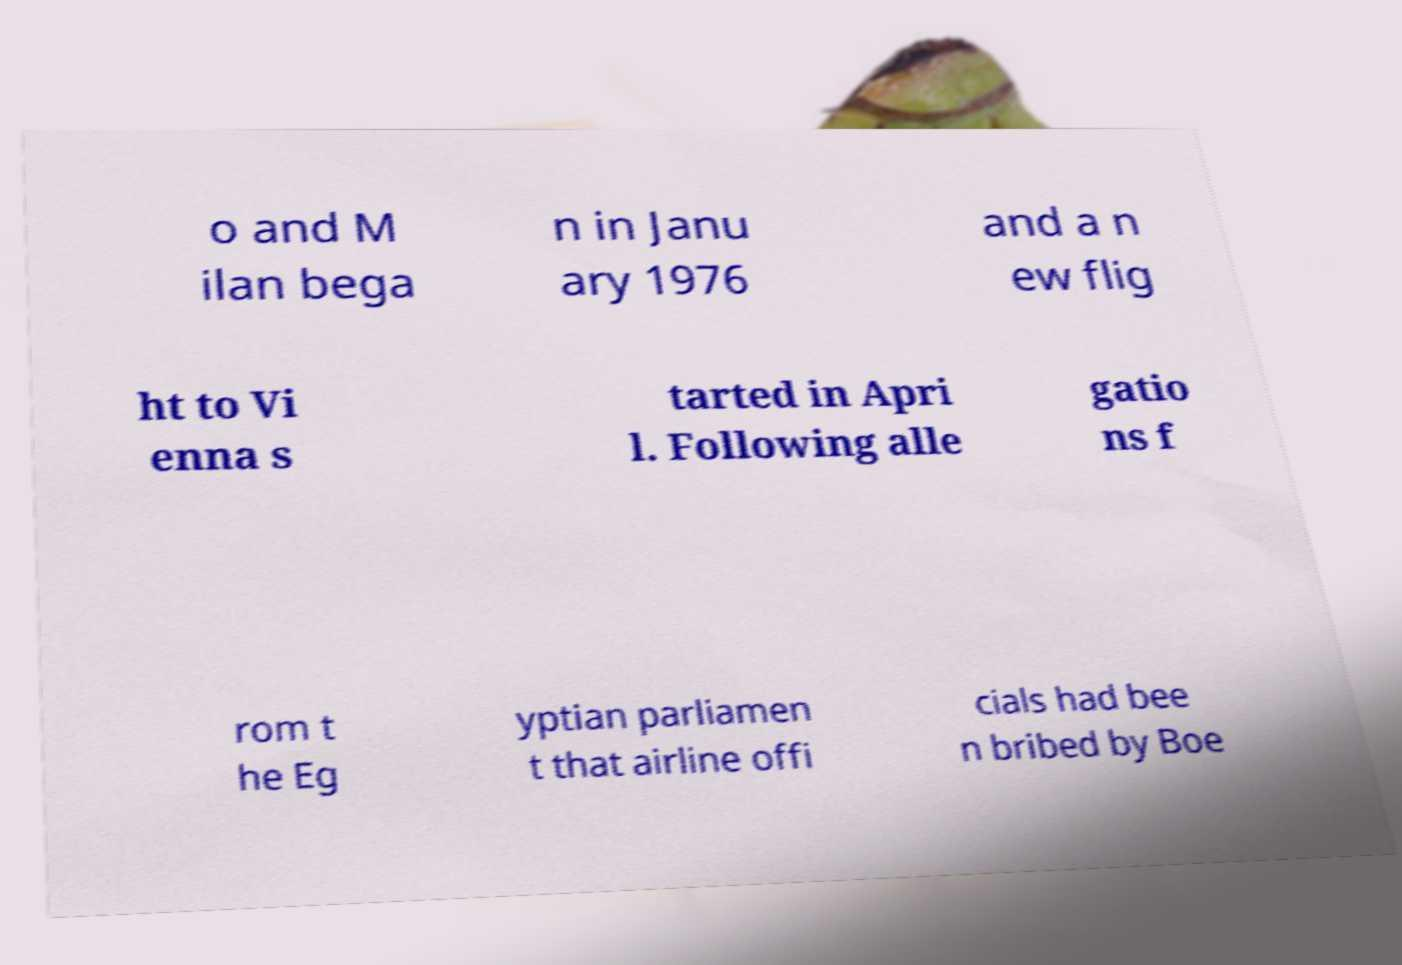For documentation purposes, I need the text within this image transcribed. Could you provide that? o and M ilan bega n in Janu ary 1976 and a n ew flig ht to Vi enna s tarted in Apri l. Following alle gatio ns f rom t he Eg yptian parliamen t that airline offi cials had bee n bribed by Boe 